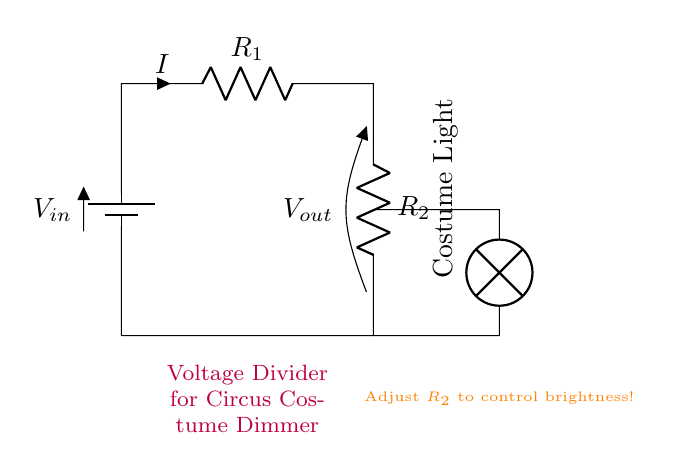What is the purpose of this circuit? The purpose of the circuit is to dim the lights of a circus costume by using a voltage divider. This is evident from the description in the diagram, which indicates it's for a "Circus Costume Dimmer".
Answer: dimming lights What type of circuit is this? This is a series circuit because all components, including resistors and the lamp, are connected in a single loop, allowing the current to flow through each component sequentially.
Answer: series circuit How many resistors are in the circuit? There are two resistors, indicated as R_1 and R_2 in the circuit diagram. They are essential for creating the voltage divider effect.
Answer: two resistors What component controls the brightness of the light? The brightness of the light is controlled by adjusting R_2. The diagram specifies to "Adjust R_2 to control brightness!" indicating it plays a crucial role in dimming the light.
Answer: R_2 What is the output voltage label in the circuit? The output voltage label is V_out, which is shown across resistor R_2. This voltage depends on the values of R_1 and R_2 and the input voltage.
Answer: V_out What is the relationship between R_1 and R_2 in this setup? In this setup, R_1 and R_2 form a voltage divider, where the output voltage (V_out) is determined by the ratio of these two resistances in series with an input voltage (V_in). As R_2 increases, V_out decreases, dimming the lamp.
Answer: voltage divider 